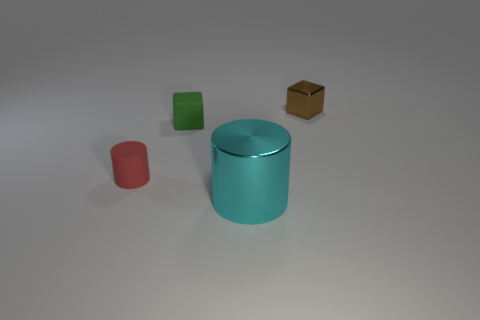Can you describe the largest object in the image? The largest object in the image is a cylindrical shape with a teal color. It's smooth and likely made of a material like plastic or metal, and it's positioned centrally among the other objects. 